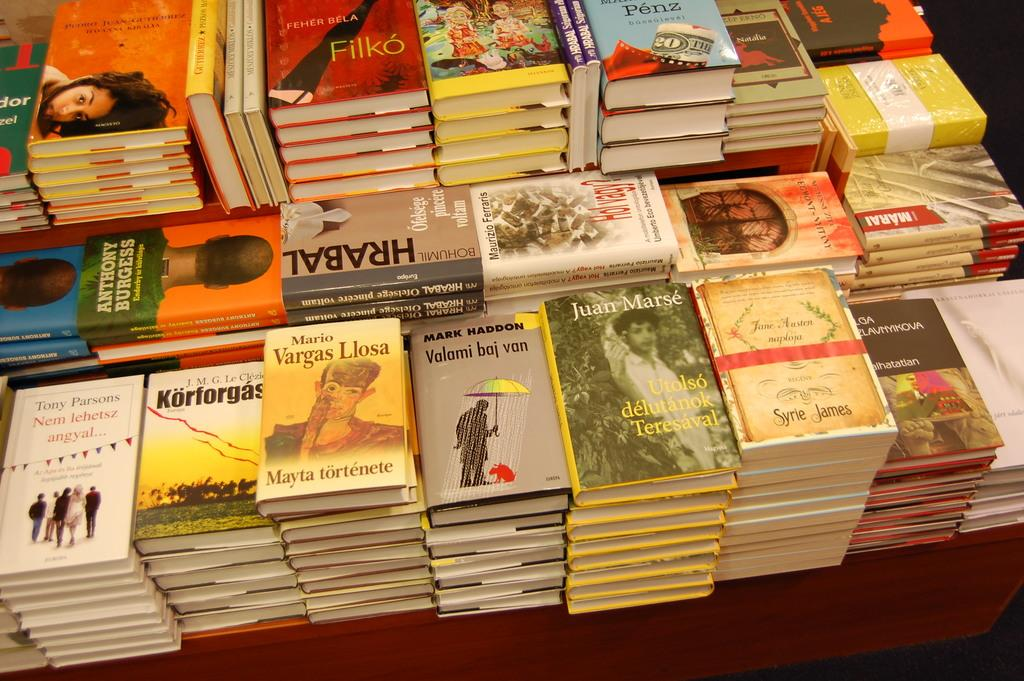<image>
Share a concise interpretation of the image provided. Stacks of books such as Mario Vargas Llosa and Hrabal sit on a table. 